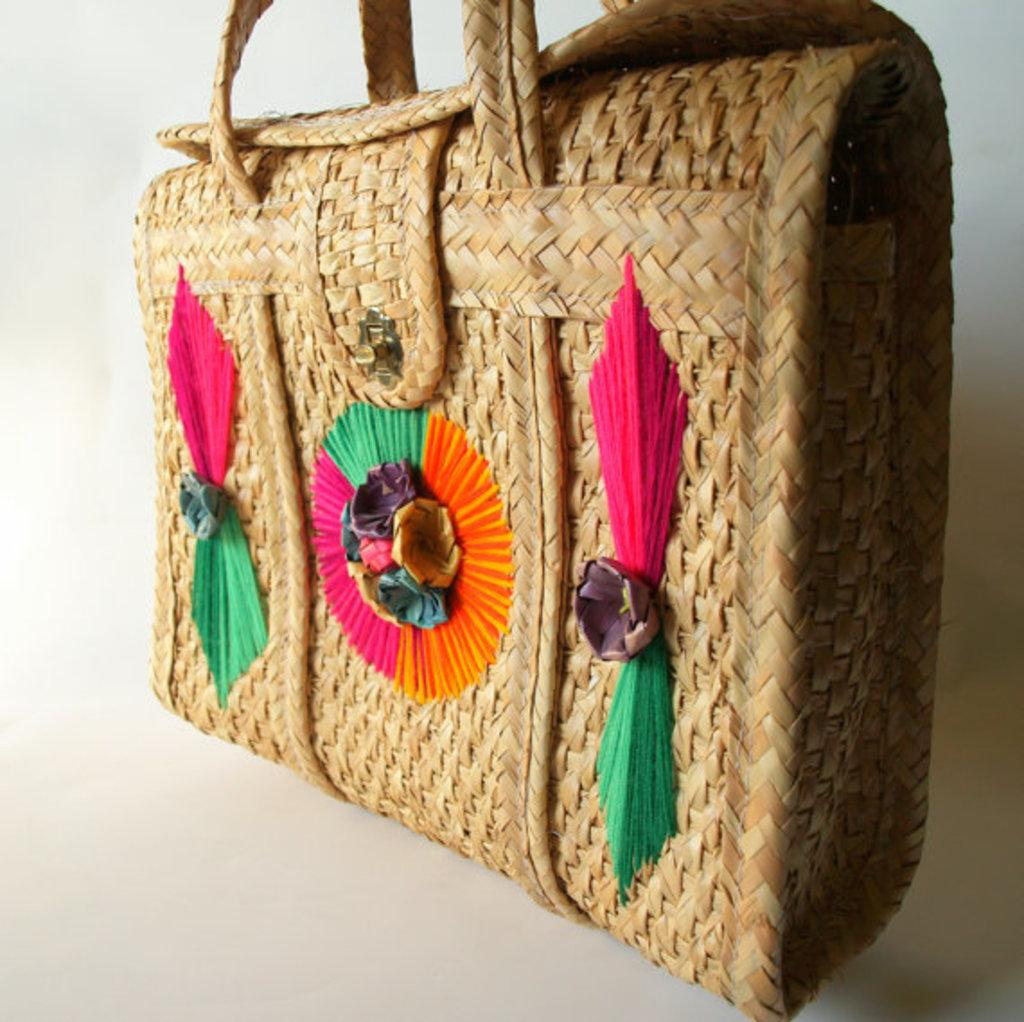What can be said about the origin of the bag in the image? The bag is handmade. Can you see a snail carrying the handmade bag in the image? There is no snail present in the image, nor is there any indication that a snail is carrying the bag. 